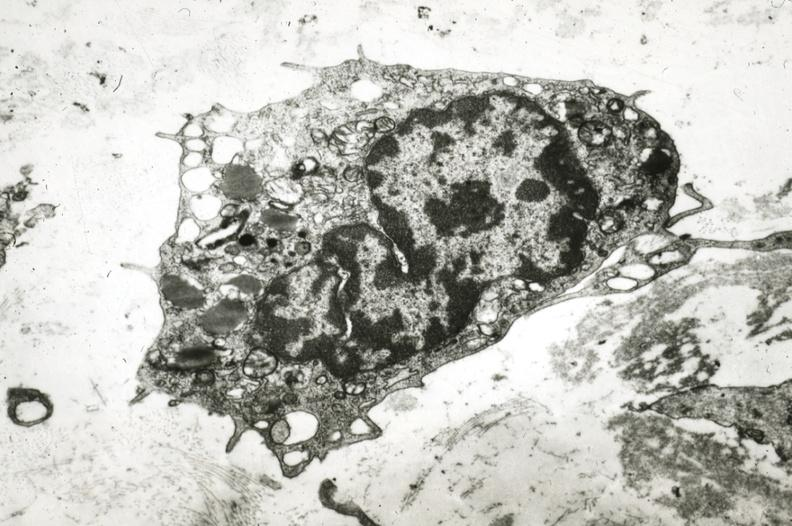what does this image show?
Answer the question using a single word or phrase. Monocyte in intima 